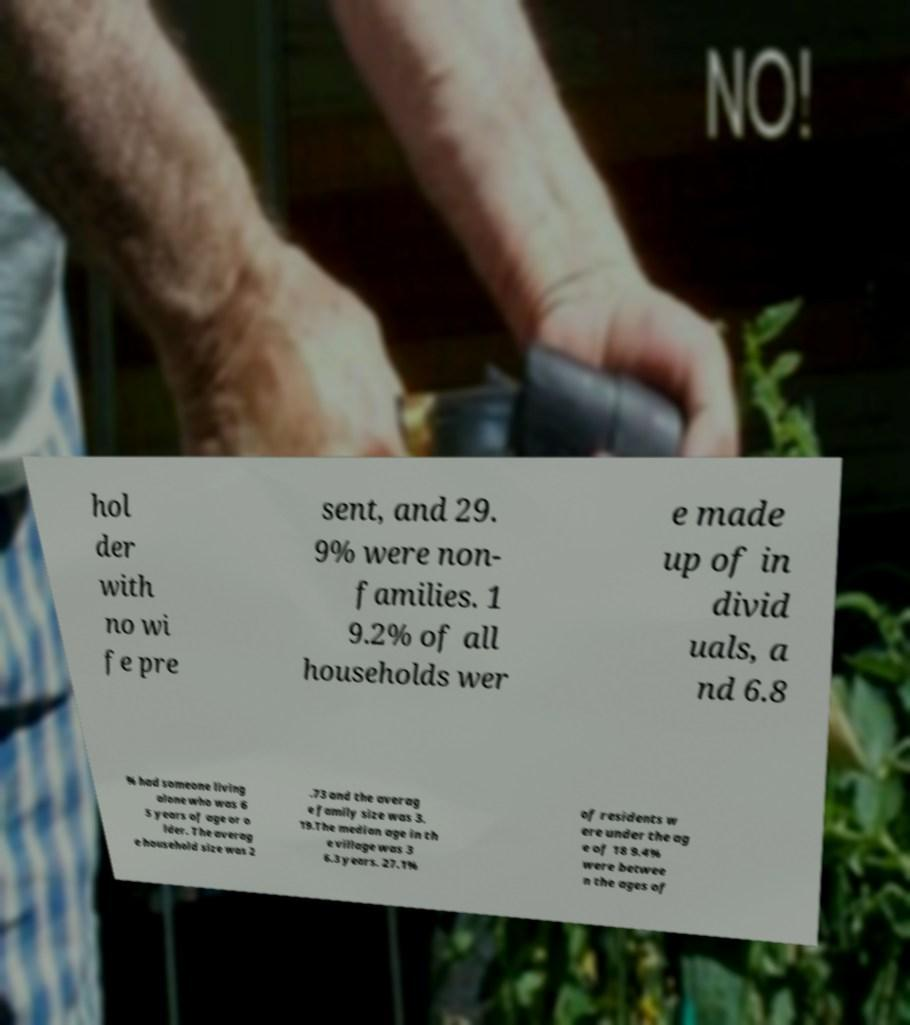Please read and relay the text visible in this image. What does it say? hol der with no wi fe pre sent, and 29. 9% were non- families. 1 9.2% of all households wer e made up of in divid uals, a nd 6.8 % had someone living alone who was 6 5 years of age or o lder. The averag e household size was 2 .73 and the averag e family size was 3. 19.The median age in th e village was 3 6.3 years. 27.1% of residents w ere under the ag e of 18 9.4% were betwee n the ages of 